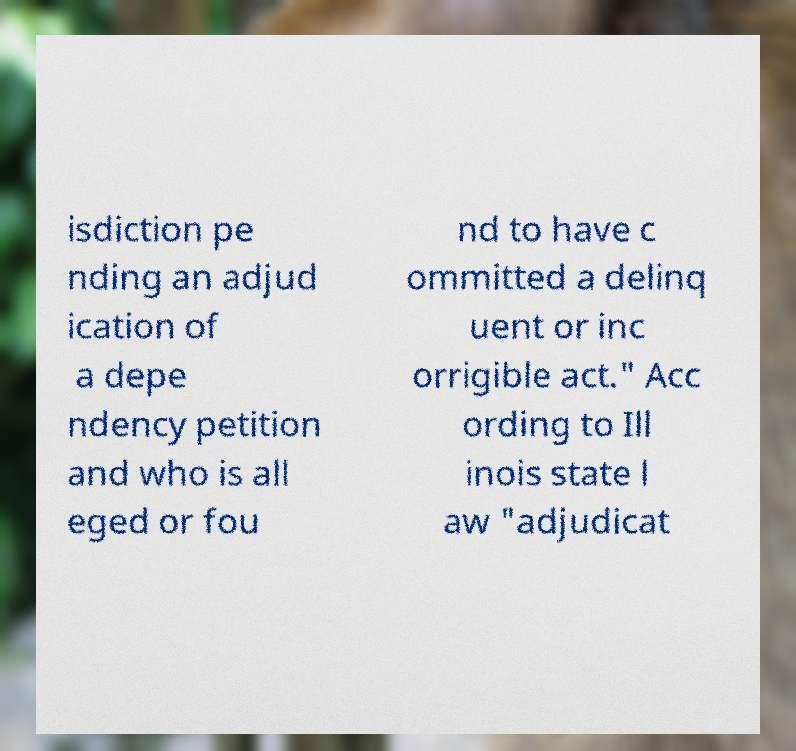Can you read and provide the text displayed in the image?This photo seems to have some interesting text. Can you extract and type it out for me? isdiction pe nding an adjud ication of a depe ndency petition and who is all eged or fou nd to have c ommitted a delinq uent or inc orrigible act." Acc ording to Ill inois state l aw "adjudicat 